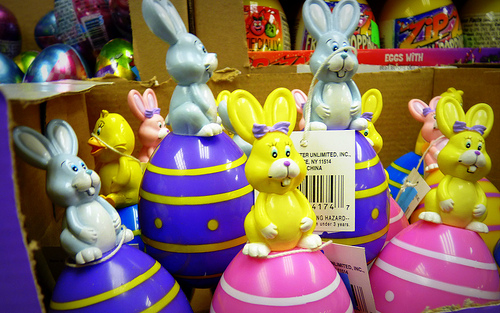<image>
Is the rabbit on the tag? Yes. Looking at the image, I can see the rabbit is positioned on top of the tag, with the tag providing support. Is the toy to the left of the toy? No. The toy is not to the left of the toy. From this viewpoint, they have a different horizontal relationship. Is there a bunny above the egg? No. The bunny is not positioned above the egg. The vertical arrangement shows a different relationship. 